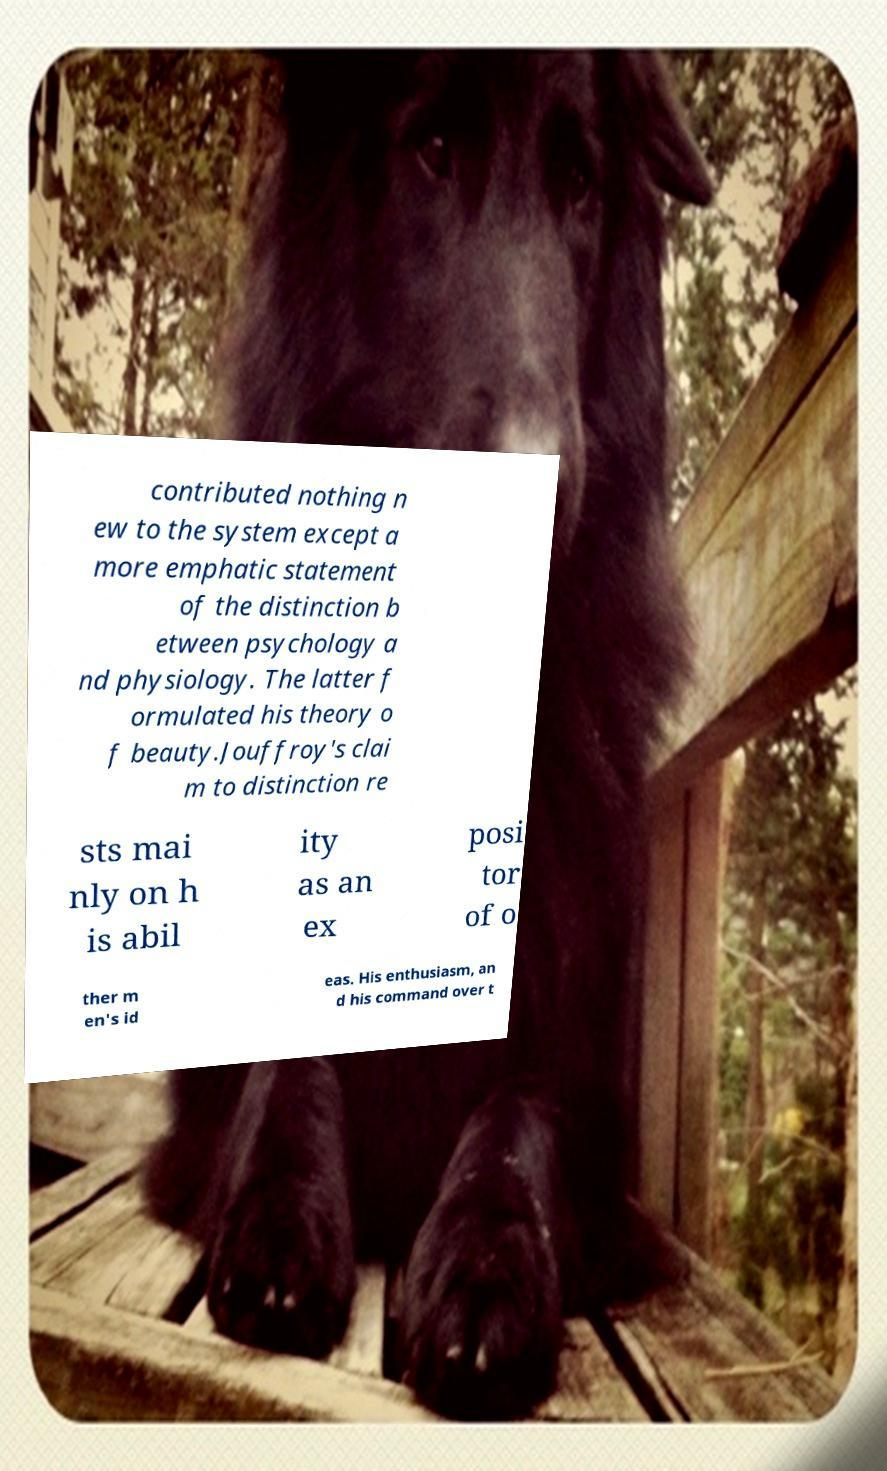For documentation purposes, I need the text within this image transcribed. Could you provide that? contributed nothing n ew to the system except a more emphatic statement of the distinction b etween psychology a nd physiology. The latter f ormulated his theory o f beauty.Jouffroy's clai m to distinction re sts mai nly on h is abil ity as an ex posi tor of o ther m en's id eas. His enthusiasm, an d his command over t 